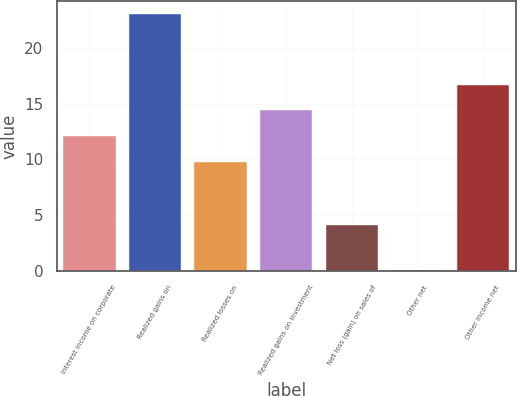Convert chart to OTSL. <chart><loc_0><loc_0><loc_500><loc_500><bar_chart><fcel>Interest income on corporate<fcel>Realized gains on<fcel>Realized losses on<fcel>Realized gains on investment<fcel>Net loss (gain) on sales of<fcel>Other net<fcel>Other income net<nl><fcel>12.09<fcel>23<fcel>9.8<fcel>14.38<fcel>4.1<fcel>0.1<fcel>16.67<nl></chart> 